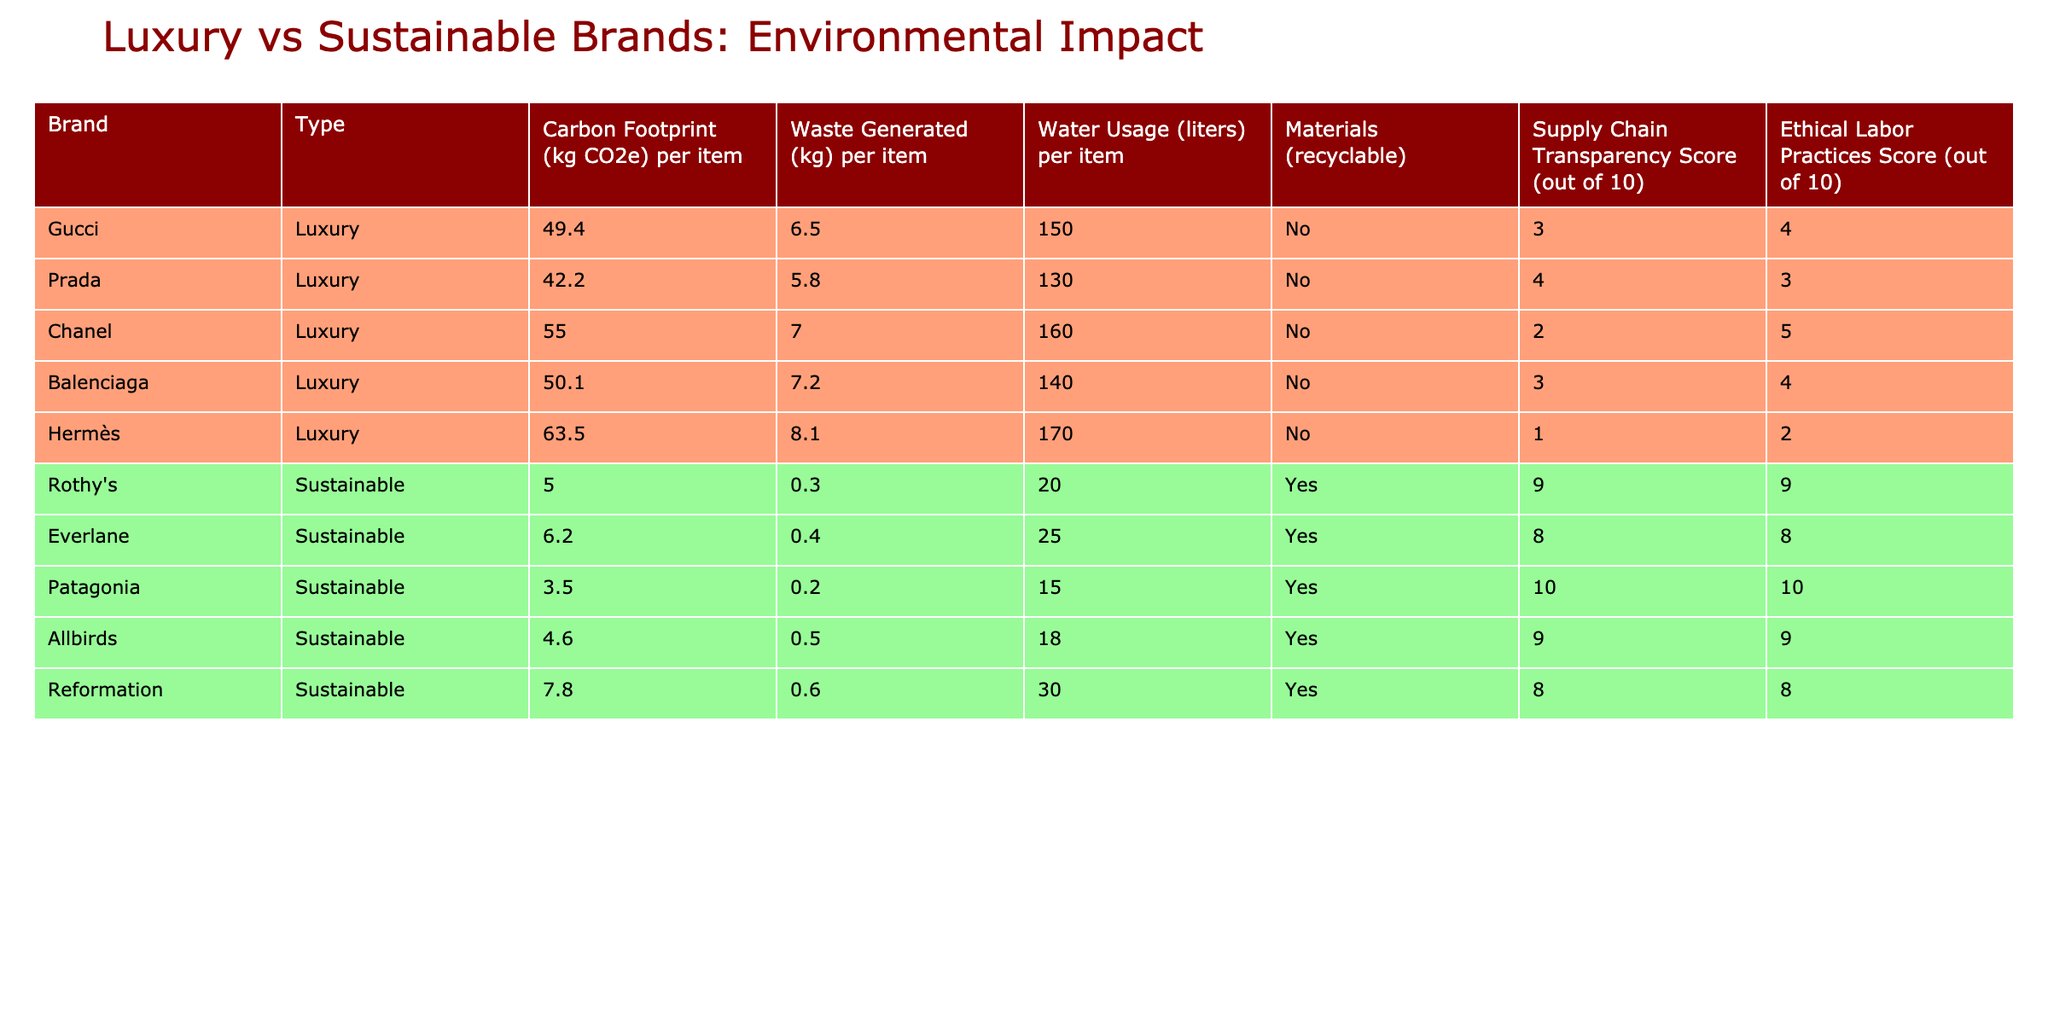What is the carbon footprint of Hermès per item? The carbon footprint of Hermès is directly listed in the table under the "Carbon Footprint (kg CO2e) per item" column. It shows a value of 63.5 kg CO2e.
Answer: 63.5 kg CO2e Which sustainable brand has the lowest water usage per item? The water usage for each sustainable brand is listed in the "Water Usage (liters) per item" column. By comparing the values, Patagonia has the lowest water usage at 15 liters.
Answer: 15 liters Is Rothy's supply chain considered transparent? Looking at the "Supply Chain Transparency Score" column, Rothy's has a score of 9, indicating it is transparent.
Answer: Yes What is the average carbon footprint of luxury brands in the table? The carbon footprints of the luxury brands are: 49.4, 42.2, 55.0, 50.1, and 63.5 kg CO2e. Summing them gives 260.2 kg CO2e. Dividing by 5 (the number of luxury brands), the average is 52.04 kg CO2e.
Answer: 52.04 kg CO2e How many sustainable brands have a waste generation of less than 0.5 kg per item? The waste generated values for sustainable brands are: 0.3, 0.4, 0.2, 0.5, and 0.6 kg. The brands with less than 0.5 kg are Rothy's, Everlane, and Patagonia, a total of 3 brands.
Answer: 3 brands What is the difference between the highest and lowest ethical labor practices score among luxury brands? The luxury brands' ethical labor practices scores are 4, 3, 5, 4, and 2. The highest score is 5 (Chanel), and the lowest is 2 (Hermès). The difference is 5 - 2 = 3.
Answer: 3 Which luxury brand has the highest waste generated per item? The waste generation for luxury brands is: 6.5, 5.8, 7.0, 7.2, and 8.1 kg. Hermès has the highest at 8.1 kg.
Answer: 8.1 kg Do all sustainable brands use recyclable materials? The "Materials (recyclable)" column indicates whether materials are recyclable. Rothy's, Everlane, Patagonia, Allbirds, and Reformation all are marked "Yes." Thus, they all use recyclable materials.
Answer: Yes What percentage of luxury brands have a supply chain transparency score of 5 or higher? There are 5 luxury brands, with scores of 3, 4, 2, 3, and 1. Only Prada (4) and Chanel (5) score 5 or higher, which is 2 out of 5. The percentage is (2/5) * 100 = 40%.
Answer: 40% Which brand uses the most water per item? The water usage values are: 150, 130, 160, 140, and 170 liters for luxury brands; and 20, 25, 15, 18, and 30 liters for sustainable brands. Comparing these, Hermès uses the most water at 170 liters.
Answer: 170 liters 